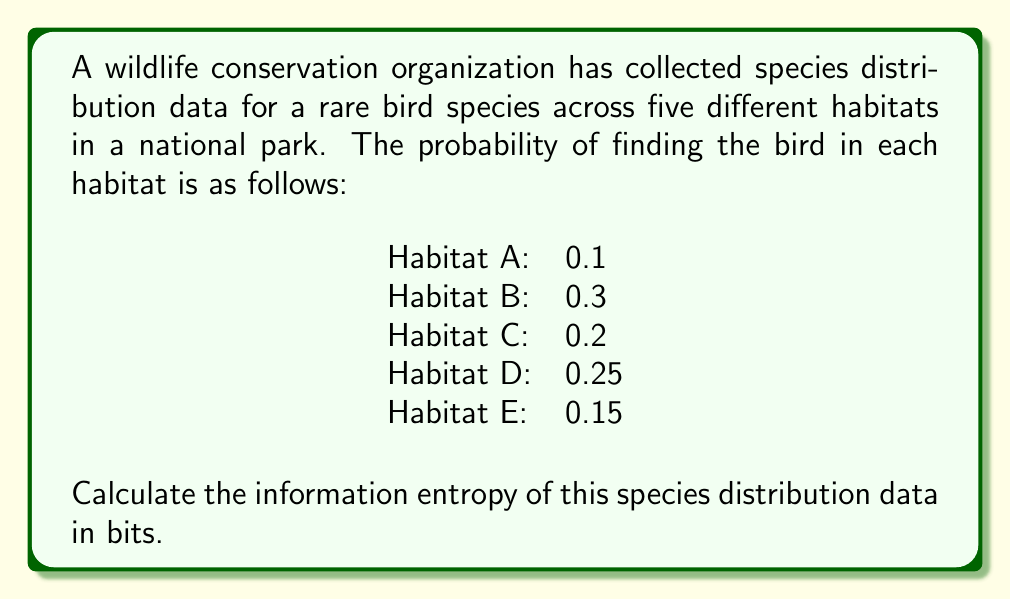Provide a solution to this math problem. To calculate the information entropy of the species distribution data, we'll use Shannon's entropy formula:

$$H = -\sum_{i=1}^n p_i \log_2(p_i)$$

Where:
$H$ is the entropy in bits
$p_i$ is the probability of the species being found in habitat $i$
$n$ is the number of habitats

Let's calculate the entropy for each habitat:

1. Habitat A: $-0.1 \log_2(0.1) = 0.3322$ bits
2. Habitat B: $-0.3 \log_2(0.3) = 0.5211$ bits
3. Habitat C: $-0.2 \log_2(0.2) = 0.4644$ bits
4. Habitat D: $-0.25 \log_2(0.25) = 0.5000$ bits
5. Habitat E: $-0.15 \log_2(0.15) = 0.4101$ bits

Now, we sum these values to get the total entropy:

$$H = 0.3322 + 0.5211 + 0.4644 + 0.5000 + 0.4101 = 2.2278 \text{ bits}$$

This result indicates the average amount of information contained in the species distribution data across the five habitats.
Answer: The information entropy of the species distribution data is approximately 2.2278 bits. 